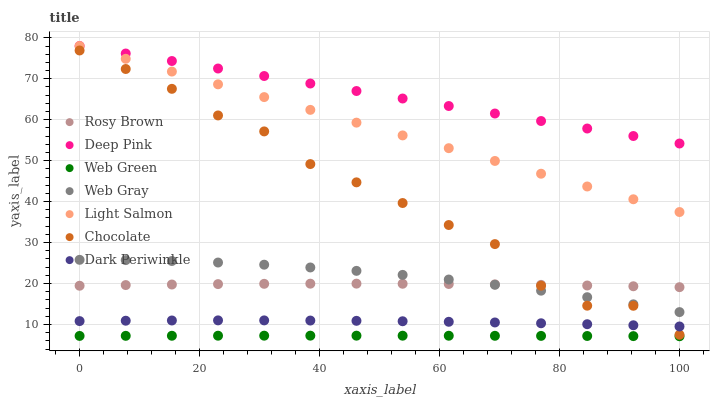Does Web Green have the minimum area under the curve?
Answer yes or no. Yes. Does Deep Pink have the maximum area under the curve?
Answer yes or no. Yes. Does Web Gray have the minimum area under the curve?
Answer yes or no. No. Does Web Gray have the maximum area under the curve?
Answer yes or no. No. Is Light Salmon the smoothest?
Answer yes or no. Yes. Is Chocolate the roughest?
Answer yes or no. Yes. Is Web Gray the smoothest?
Answer yes or no. No. Is Web Gray the roughest?
Answer yes or no. No. Does Web Green have the lowest value?
Answer yes or no. Yes. Does Web Gray have the lowest value?
Answer yes or no. No. Does Deep Pink have the highest value?
Answer yes or no. Yes. Does Web Gray have the highest value?
Answer yes or no. No. Is Web Green less than Dark Periwinkle?
Answer yes or no. Yes. Is Web Gray greater than Web Green?
Answer yes or no. Yes. Does Rosy Brown intersect Chocolate?
Answer yes or no. Yes. Is Rosy Brown less than Chocolate?
Answer yes or no. No. Is Rosy Brown greater than Chocolate?
Answer yes or no. No. Does Web Green intersect Dark Periwinkle?
Answer yes or no. No. 